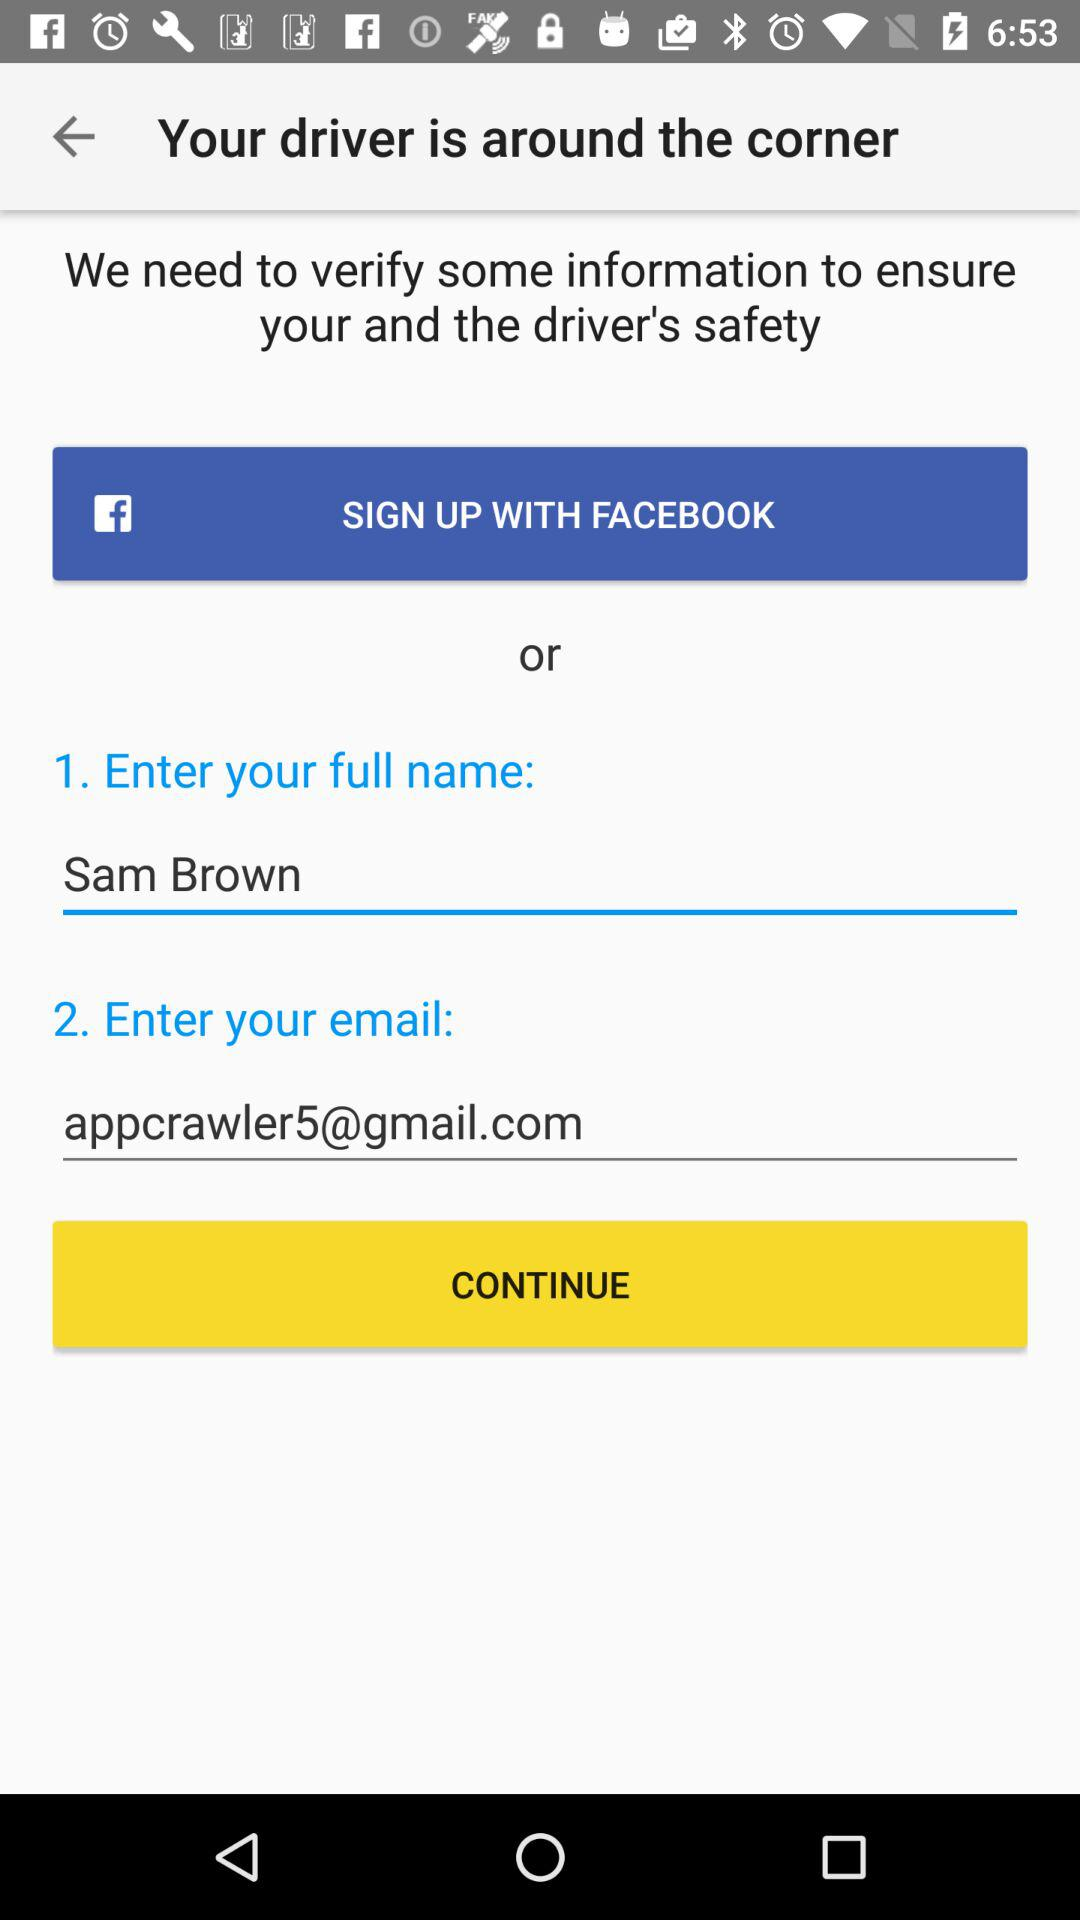What is the full name? The full name is Sam Brown. 